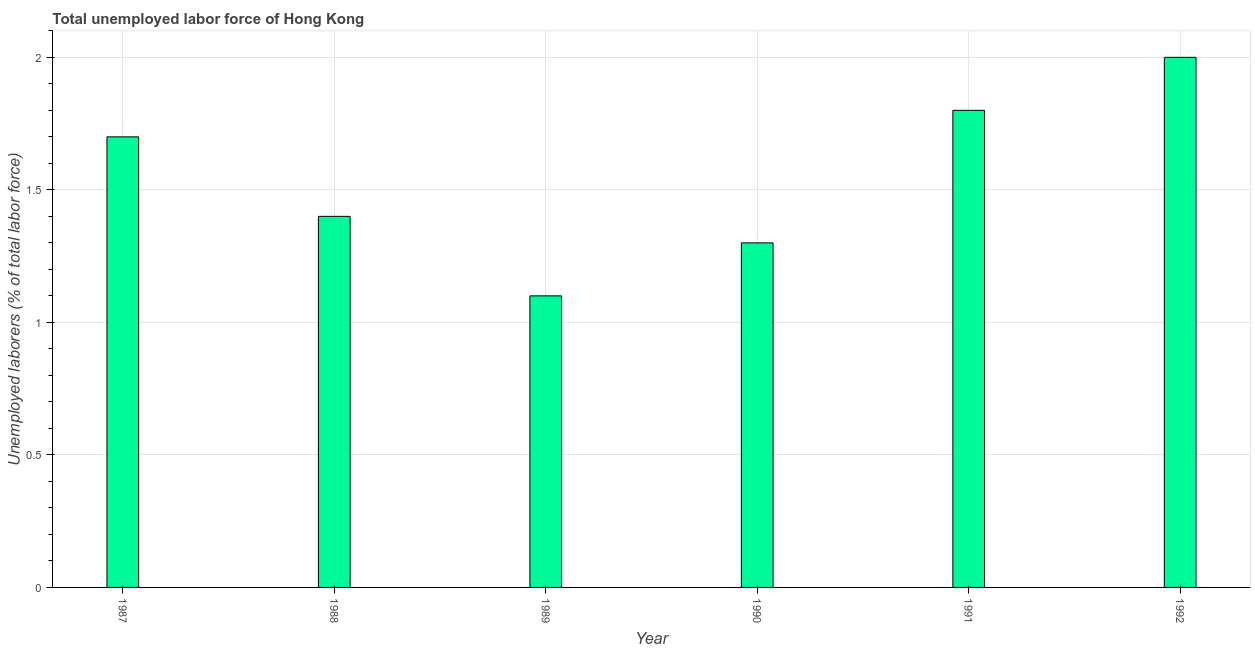Does the graph contain any zero values?
Offer a very short reply. No. Does the graph contain grids?
Your answer should be very brief. Yes. What is the title of the graph?
Ensure brevity in your answer.  Total unemployed labor force of Hong Kong. What is the label or title of the X-axis?
Make the answer very short. Year. What is the label or title of the Y-axis?
Offer a very short reply. Unemployed laborers (% of total labor force). Across all years, what is the minimum total unemployed labour force?
Offer a terse response. 1.1. In which year was the total unemployed labour force minimum?
Ensure brevity in your answer.  1989. What is the sum of the total unemployed labour force?
Offer a very short reply. 9.3. What is the average total unemployed labour force per year?
Provide a succinct answer. 1.55. What is the median total unemployed labour force?
Provide a succinct answer. 1.55. In how many years, is the total unemployed labour force greater than 1.6 %?
Your answer should be very brief. 3. Do a majority of the years between 1991 and 1989 (inclusive) have total unemployed labour force greater than 1 %?
Ensure brevity in your answer.  Yes. What is the ratio of the total unemployed labour force in 1987 to that in 1990?
Provide a short and direct response. 1.31. What is the difference between the highest and the second highest total unemployed labour force?
Provide a succinct answer. 0.2. What is the difference between the highest and the lowest total unemployed labour force?
Your response must be concise. 0.9. How many bars are there?
Keep it short and to the point. 6. How many years are there in the graph?
Make the answer very short. 6. What is the difference between two consecutive major ticks on the Y-axis?
Your answer should be very brief. 0.5. What is the Unemployed laborers (% of total labor force) of 1987?
Keep it short and to the point. 1.7. What is the Unemployed laborers (% of total labor force) in 1988?
Your answer should be compact. 1.4. What is the Unemployed laborers (% of total labor force) of 1989?
Provide a short and direct response. 1.1. What is the Unemployed laborers (% of total labor force) in 1990?
Provide a succinct answer. 1.3. What is the Unemployed laborers (% of total labor force) of 1991?
Provide a short and direct response. 1.8. What is the Unemployed laborers (% of total labor force) in 1992?
Your answer should be very brief. 2. What is the difference between the Unemployed laborers (% of total labor force) in 1987 and 1988?
Your response must be concise. 0.3. What is the difference between the Unemployed laborers (% of total labor force) in 1987 and 1989?
Provide a succinct answer. 0.6. What is the difference between the Unemployed laborers (% of total labor force) in 1987 and 1991?
Offer a very short reply. -0.1. What is the difference between the Unemployed laborers (% of total labor force) in 1987 and 1992?
Make the answer very short. -0.3. What is the difference between the Unemployed laborers (% of total labor force) in 1989 and 1991?
Your response must be concise. -0.7. What is the difference between the Unemployed laborers (% of total labor force) in 1989 and 1992?
Give a very brief answer. -0.9. What is the ratio of the Unemployed laborers (% of total labor force) in 1987 to that in 1988?
Provide a short and direct response. 1.21. What is the ratio of the Unemployed laborers (% of total labor force) in 1987 to that in 1989?
Your answer should be compact. 1.54. What is the ratio of the Unemployed laborers (% of total labor force) in 1987 to that in 1990?
Ensure brevity in your answer.  1.31. What is the ratio of the Unemployed laborers (% of total labor force) in 1987 to that in 1991?
Ensure brevity in your answer.  0.94. What is the ratio of the Unemployed laborers (% of total labor force) in 1988 to that in 1989?
Provide a succinct answer. 1.27. What is the ratio of the Unemployed laborers (% of total labor force) in 1988 to that in 1990?
Provide a succinct answer. 1.08. What is the ratio of the Unemployed laborers (% of total labor force) in 1988 to that in 1991?
Offer a very short reply. 0.78. What is the ratio of the Unemployed laborers (% of total labor force) in 1988 to that in 1992?
Keep it short and to the point. 0.7. What is the ratio of the Unemployed laborers (% of total labor force) in 1989 to that in 1990?
Provide a short and direct response. 0.85. What is the ratio of the Unemployed laborers (% of total labor force) in 1989 to that in 1991?
Offer a terse response. 0.61. What is the ratio of the Unemployed laborers (% of total labor force) in 1989 to that in 1992?
Give a very brief answer. 0.55. What is the ratio of the Unemployed laborers (% of total labor force) in 1990 to that in 1991?
Offer a terse response. 0.72. What is the ratio of the Unemployed laborers (% of total labor force) in 1990 to that in 1992?
Provide a short and direct response. 0.65. What is the ratio of the Unemployed laborers (% of total labor force) in 1991 to that in 1992?
Make the answer very short. 0.9. 